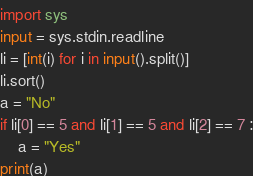Convert code to text. <code><loc_0><loc_0><loc_500><loc_500><_Python_>import sys
input = sys.stdin.readline
li = [int(i) for i in input().split()]
li.sort()
a = "No"
if li[0] == 5 and li[1] == 5 and li[2] == 7 :
    a = "Yes"
print(a)</code> 